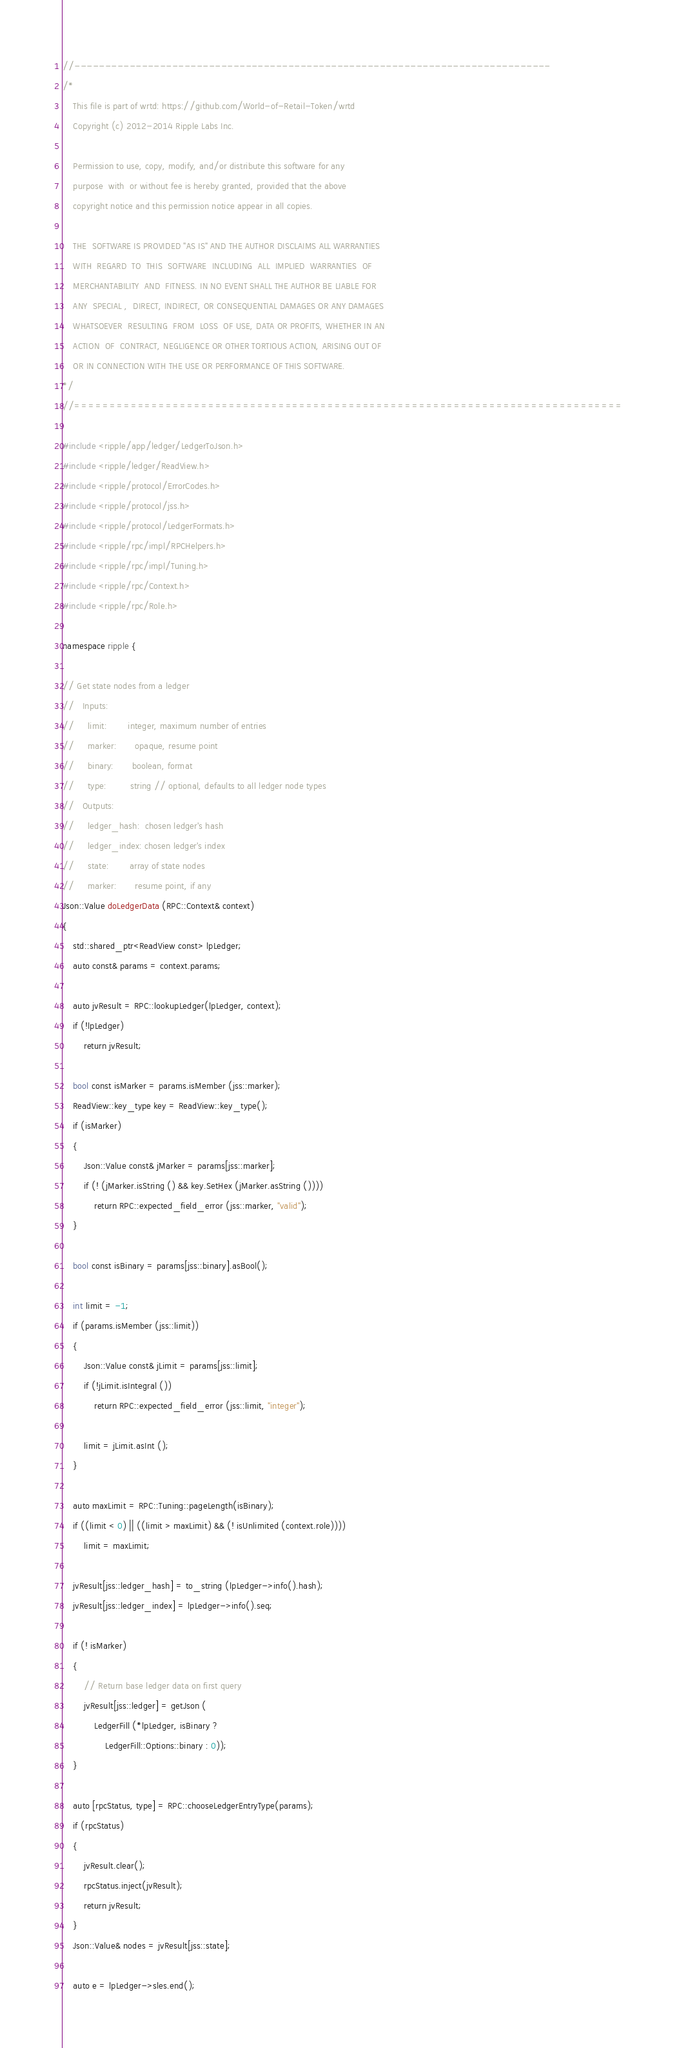Convert code to text. <code><loc_0><loc_0><loc_500><loc_500><_C++_>//------------------------------------------------------------------------------
/*
    This file is part of wrtd: https://github.com/World-of-Retail-Token/wrtd
    Copyright (c) 2012-2014 Ripple Labs Inc.

    Permission to use, copy, modify, and/or distribute this software for any
    purpose  with  or without fee is hereby granted, provided that the above
    copyright notice and this permission notice appear in all copies.

    THE  SOFTWARE IS PROVIDED "AS IS" AND THE AUTHOR DISCLAIMS ALL WARRANTIES
    WITH  REGARD  TO  THIS  SOFTWARE  INCLUDING  ALL  IMPLIED  WARRANTIES  OF
    MERCHANTABILITY  AND  FITNESS. IN NO EVENT SHALL THE AUTHOR BE LIABLE FOR
    ANY  SPECIAL ,  DIRECT, INDIRECT, OR CONSEQUENTIAL DAMAGES OR ANY DAMAGES
    WHATSOEVER  RESULTING  FROM  LOSS  OF USE, DATA OR PROFITS, WHETHER IN AN
    ACTION  OF  CONTRACT, NEGLIGENCE OR OTHER TORTIOUS ACTION, ARISING OUT OF
    OR IN CONNECTION WITH THE USE OR PERFORMANCE OF THIS SOFTWARE.
*/
//==============================================================================

#include <ripple/app/ledger/LedgerToJson.h>
#include <ripple/ledger/ReadView.h>
#include <ripple/protocol/ErrorCodes.h>
#include <ripple/protocol/jss.h>
#include <ripple/protocol/LedgerFormats.h>
#include <ripple/rpc/impl/RPCHelpers.h>
#include <ripple/rpc/impl/Tuning.h>
#include <ripple/rpc/Context.h>
#include <ripple/rpc/Role.h>

namespace ripple {

// Get state nodes from a ledger
//   Inputs:
//     limit:        integer, maximum number of entries
//     marker:       opaque, resume point
//     binary:       boolean, format
//     type:         string // optional, defaults to all ledger node types
//   Outputs:
//     ledger_hash:  chosen ledger's hash
//     ledger_index: chosen ledger's index
//     state:        array of state nodes
//     marker:       resume point, if any
Json::Value doLedgerData (RPC::Context& context)
{
    std::shared_ptr<ReadView const> lpLedger;
    auto const& params = context.params;

    auto jvResult = RPC::lookupLedger(lpLedger, context);
    if (!lpLedger)
        return jvResult;

    bool const isMarker = params.isMember (jss::marker);
    ReadView::key_type key = ReadView::key_type();
    if (isMarker)
    {
        Json::Value const& jMarker = params[jss::marker];
        if (! (jMarker.isString () && key.SetHex (jMarker.asString ())))
            return RPC::expected_field_error (jss::marker, "valid");
    }

    bool const isBinary = params[jss::binary].asBool();

    int limit = -1;
    if (params.isMember (jss::limit))
    {
        Json::Value const& jLimit = params[jss::limit];
        if (!jLimit.isIntegral ())
            return RPC::expected_field_error (jss::limit, "integer");

        limit = jLimit.asInt ();
    }

    auto maxLimit = RPC::Tuning::pageLength(isBinary);
    if ((limit < 0) || ((limit > maxLimit) && (! isUnlimited (context.role))))
        limit = maxLimit;

    jvResult[jss::ledger_hash] = to_string (lpLedger->info().hash);
    jvResult[jss::ledger_index] = lpLedger->info().seq;

    if (! isMarker)
    {
        // Return base ledger data on first query
        jvResult[jss::ledger] = getJson (
            LedgerFill (*lpLedger, isBinary ?
                LedgerFill::Options::binary : 0));
    }

    auto [rpcStatus, type] = RPC::chooseLedgerEntryType(params);
    if (rpcStatus)
    {
        jvResult.clear();
        rpcStatus.inject(jvResult);
        return jvResult;
    }
    Json::Value& nodes = jvResult[jss::state];

    auto e = lpLedger->sles.end();</code> 